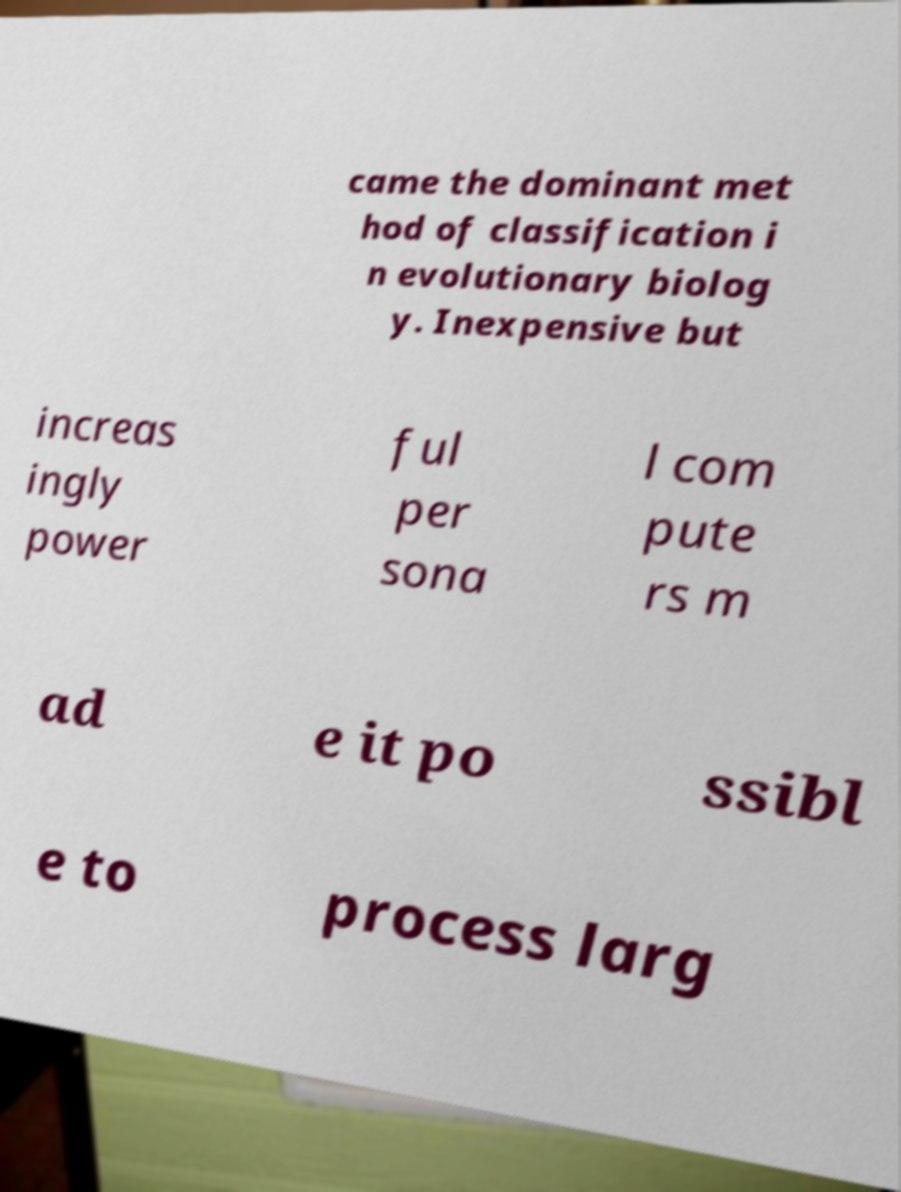Can you read and provide the text displayed in the image?This photo seems to have some interesting text. Can you extract and type it out for me? came the dominant met hod of classification i n evolutionary biolog y. Inexpensive but increas ingly power ful per sona l com pute rs m ad e it po ssibl e to process larg 